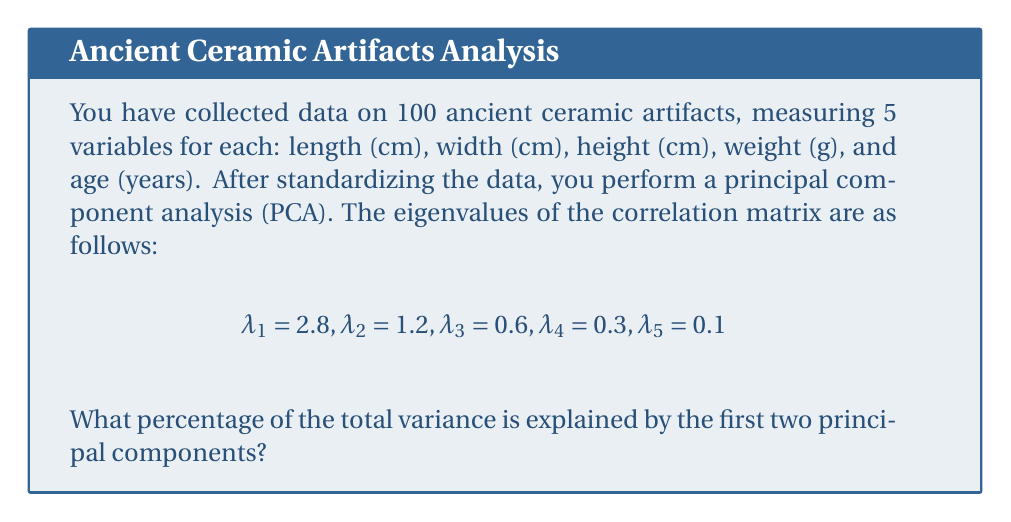Solve this math problem. To solve this problem, we need to follow these steps:

1) First, recall that in PCA, each eigenvalue represents the amount of variance explained by its corresponding principal component.

2) The total variance in a standardized dataset is equal to the number of variables. In this case, we have 5 variables, so the total variance is 5.

3) We can verify this by summing all the eigenvalues:

   $$2.8 + 1.2 + 0.6 + 0.3 + 0.1 = 5$$

4) To find the percentage of variance explained by the first two principal components, we need to:
   a) Sum the first two eigenvalues
   b) Divide this sum by the total variance
   c) Multiply by 100 to get a percentage

5) Let's perform these calculations:

   a) Sum of first two eigenvalues: $2.8 + 1.2 = 4$
   
   b) Proportion of variance explained: $\frac{4}{5} = 0.8$
   
   c) Percentage: $0.8 \times 100 = 80\%$

Therefore, the first two principal components explain 80% of the total variance in the dataset.
Answer: 80% 